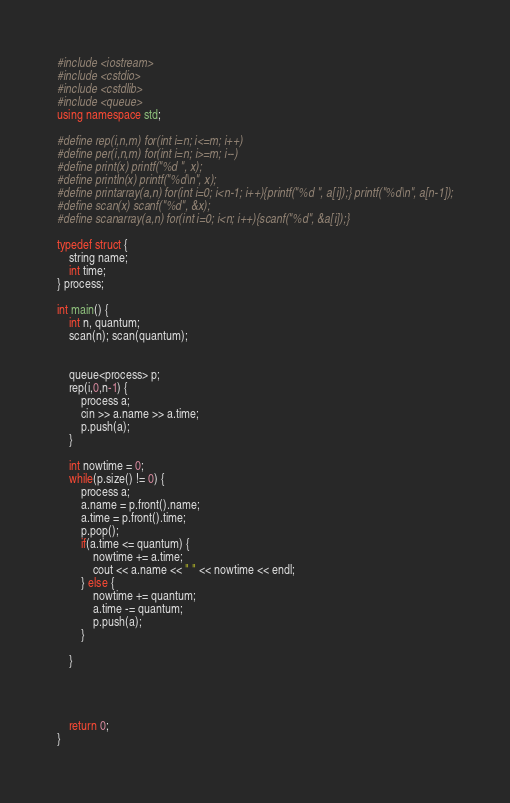<code> <loc_0><loc_0><loc_500><loc_500><_C++_>#include <iostream>
#include <cstdio>
#include <cstdlib>
#include <queue>
using namespace std;

#define rep(i,n,m) for(int i=n; i<=m; i++)
#define per(i,n,m) for(int i=n; i>=m; i--)
#define print(x) printf("%d ", x);
#define println(x) printf("%d\n", x);
#define printarray(a,n) for(int i=0; i<n-1; i++){printf("%d ", a[i]);} printf("%d\n", a[n-1]);
#define scan(x) scanf("%d", &x);
#define scanarray(a,n) for(int i=0; i<n; i++){scanf("%d", &a[i]);}

typedef struct {
    string name;
    int time;
} process;

int main() {
    int n, quantum;
    scan(n); scan(quantum);
    
    
    queue<process> p;
    rep(i,0,n-1) {
    	process a;
        cin >> a.name >> a.time;
    	p.push(a);
    }
    
    int nowtime = 0;
    while(p.size() != 0) {
        process a;
        a.name = p.front().name;
        a.time = p.front().time;
        p.pop();
        if(a.time <= quantum) {
            nowtime += a.time;
            cout << a.name << " " << nowtime << endl;
        } else {
            nowtime += quantum;
            a.time -= quantum;
            p.push(a);
        }
        
    }
	
    
    
    
    return 0;
}
</code> 